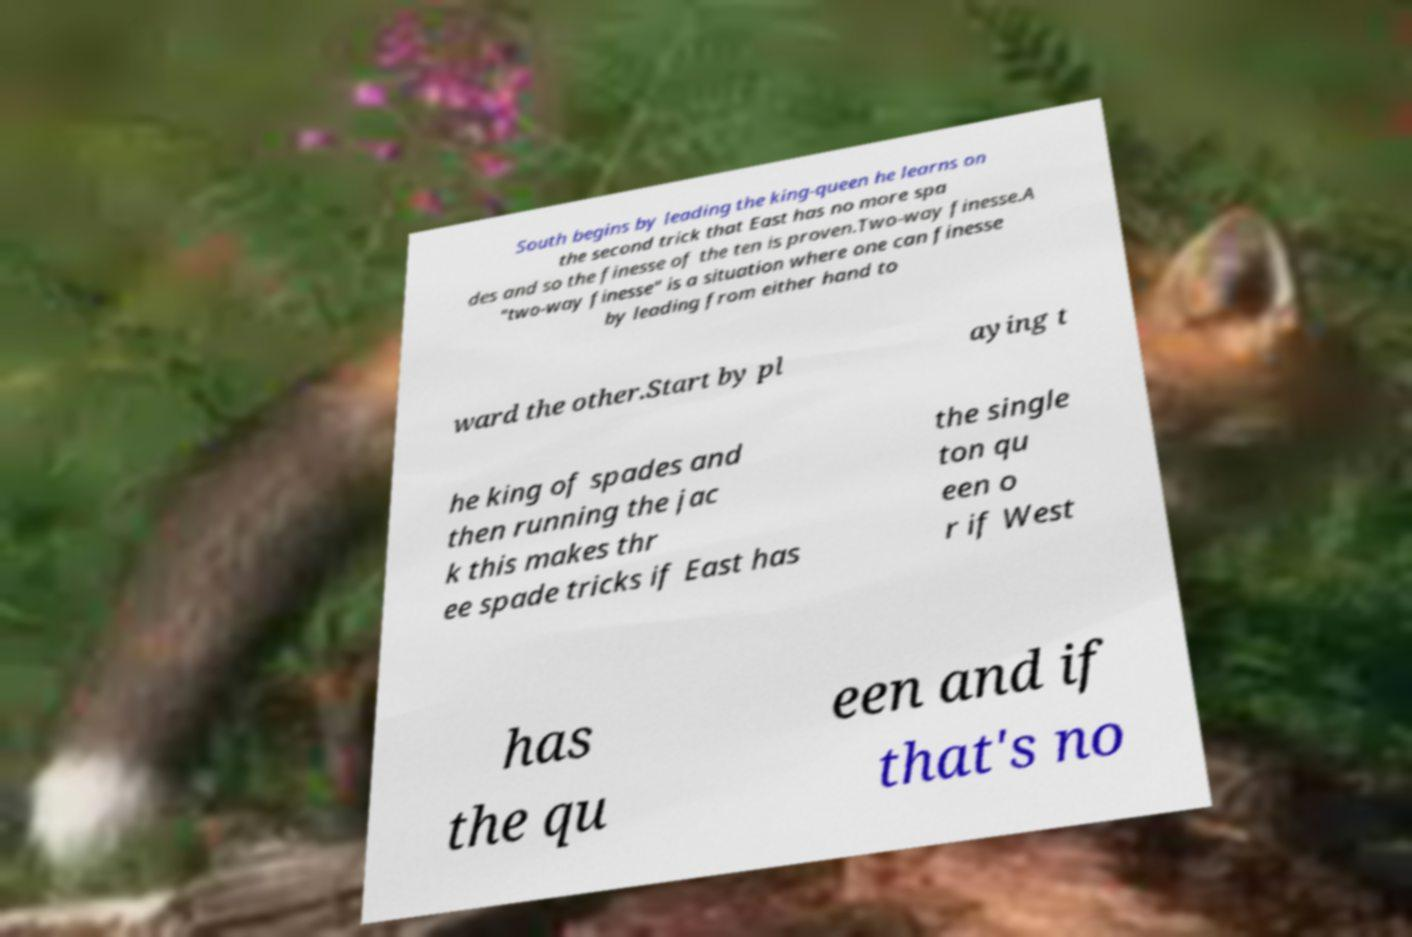What messages or text are displayed in this image? I need them in a readable, typed format. South begins by leading the king-queen he learns on the second trick that East has no more spa des and so the finesse of the ten is proven.Two-way finesse.A "two-way finesse" is a situation where one can finesse by leading from either hand to ward the other.Start by pl aying t he king of spades and then running the jac k this makes thr ee spade tricks if East has the single ton qu een o r if West has the qu een and if that's no 